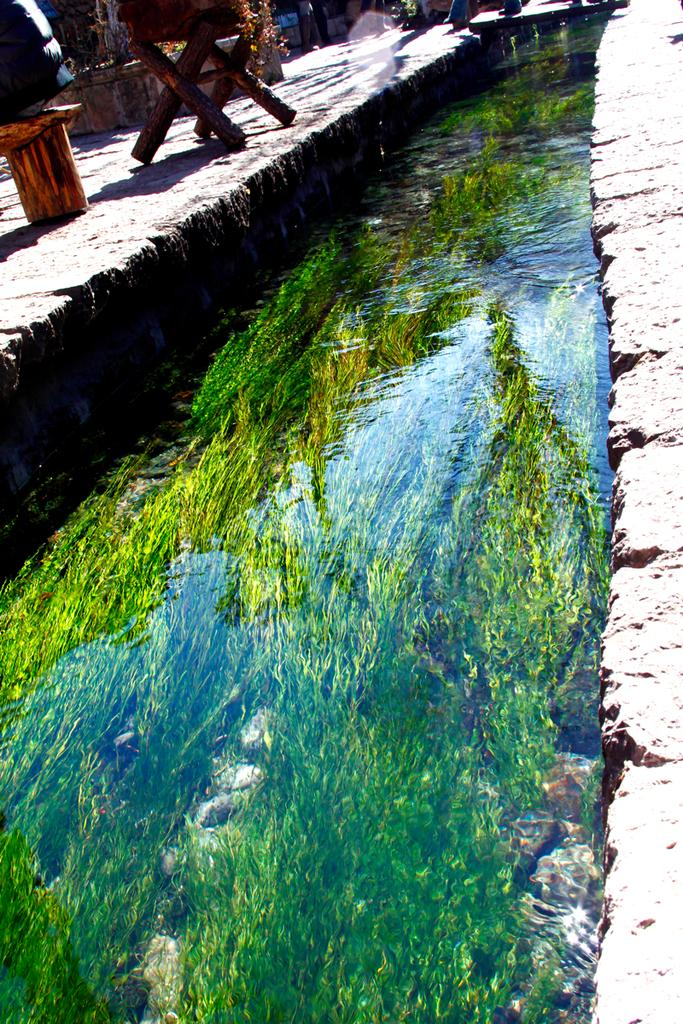What type of vegetation is present in the image? There is grass in the image. What else can be seen in the image besides grass? There is water, stones, people, tables, flowers, and a floor in the image. What might the people be using the tables for in the image? The tables could be used for various purposes, such as eating, working, or playing games. What is the texture of the floor in the image? The texture of the floor is not visible in the image. What type of leather is visible on the flag in the image? There is no flag or leather present in the image. Who is the writer in the image? There is no writer present in the image. 